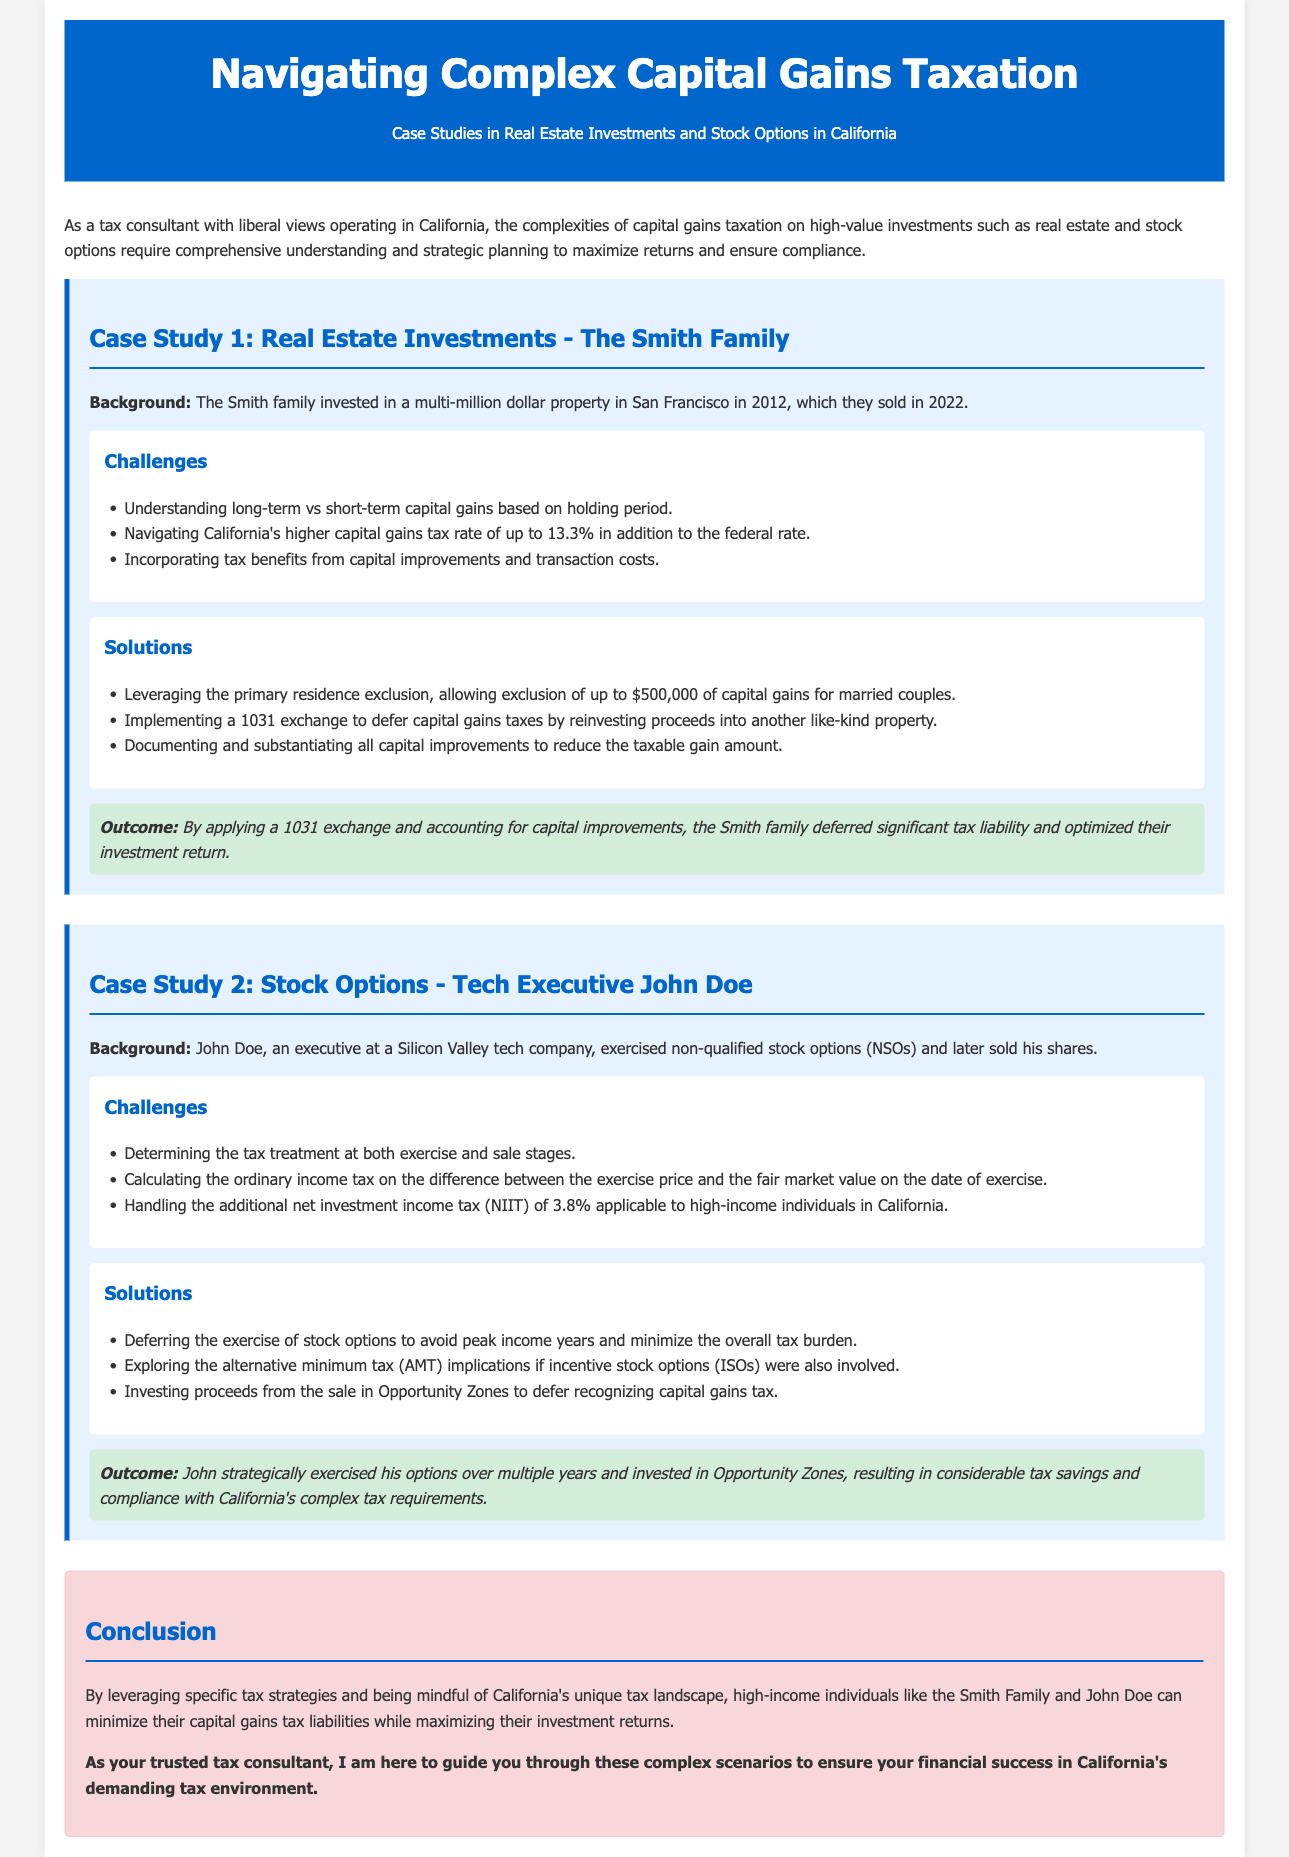What is the title of the document? The title is presented in the header of the document.
Answer: Navigating Complex Capital Gains Taxation Who are the subjects of Case Study 1? The subjects are introduced at the beginning of the case study section.
Answer: The Smith Family What year did the Smith family sell their property? The year is stated in the background information of the case study.
Answer: 2022 What is the maximum capital gains exclusion for married couples? The exclusion amount is mentioned in the solutions section.
Answer: $500,000 What alternative tax strategy did John Doe use? The strategy is detailed in the solutions of his case study.
Answer: Opportunity Zones What is the capital gains tax rate in California? The tax rate is indicated alongside challenges faced in Case Study 1.
Answer: Up to 13.3% What implication is discussed regarding non-qualified stock options? The implication is part of the challenges faced in Case Study 2.
Answer: Tax treatment at both exercise and sale stages What did the Smith family do to defer their capital gains tax? The action is mentioned in the solutions to Case Study 1.
Answer: 1031 exchange What is the outcome of John Doe's investment strategy? The outcome is summarized at the end of Case Study 2.
Answer: Considerable tax savings and compliance 